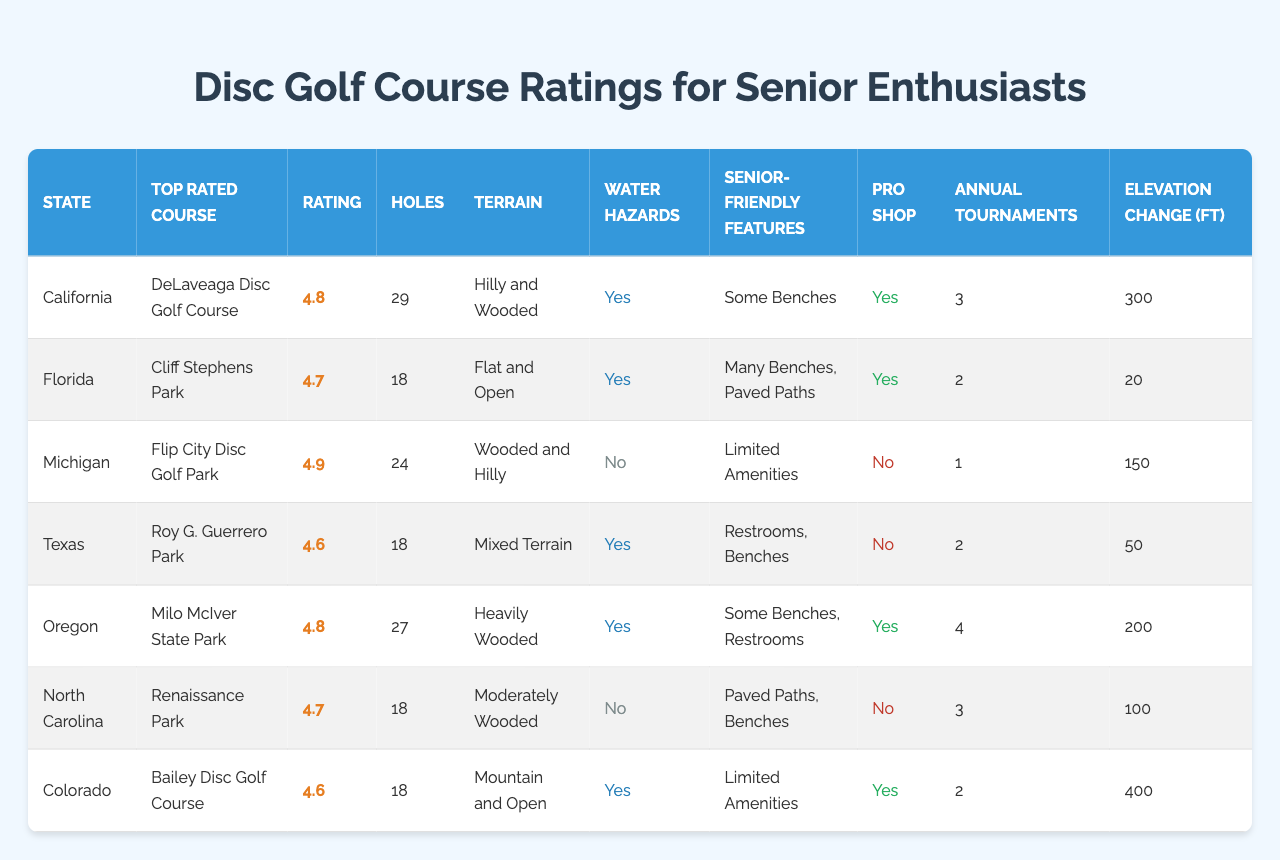What is the top-rated disc golf course in Oregon? Looking at the "Top Rated Course" column for Oregon, the entry shows "Milo McIver State Park" as the top-rated course.
Answer: Milo McIver State Park Which state has the highest course rating? The highest course rating can be found by scanning the "Course Rating" column, where Flip City Disc Golf Park in Michigan has a rating of 4.9, the highest among all states.
Answer: Michigan How many holes does the top-rated course in California have? Referring to California's entry in the "Number of Holes" column, DeLaveaga Disc Golf Course has 29 holes.
Answer: 29 Is there a pro shop on-site at the top-rated course in Florida? Checking Florida's entry under "Pro Shop on Site," it states "Yes," indicating that there is a pro shop at Cliff Stephens Park.
Answer: Yes What is the average course rating of all the courses listed? To find the average, first, sum the ratings: (4.8 + 4.7 + 4.9 + 4.6 + 4.8 + 4.7 + 4.6) = 33.1. There are 7 courses, so the average is 33.1 / 7 = 4.73.
Answer: 4.73 Which states have water hazards, and how many of them are listed? Looking at the "Water Hazards" column, the states with "Yes" entries are California, Florida, Texas, Oregon, and Colorado. That's a total of 5 states with water hazards.
Answer: 5 What is the state with the least number of annual tournaments held? By examining the "Tournaments Held Annually" column, the values for Michigan, Colorado, and Florida show the least numbers: 1 and 2. Michigan has the least with 1 tournament.
Answer: Michigan Which disc golf course has the most senior-friendly features? Analyzing the "Senior-Friendly Features" column, we see that Cliff Stephens Park in Florida offers "Many Benches, Paved Paths," which can be considered the most accommodating for seniors.
Answer: Cliff Stephens Park What is the elevation change difference between the highest and lowest listed courses? The highest elevation change is 400 feet for Bailey Disc Golf Course, and the lowest is 20 feet for Cliff Stephens Park. The difference is 400 - 20 = 380 feet.
Answer: 380 feet Are any courses listed as having limited amenities for seniors? Checking the "Senior-Friendly Features," both Flip City Disc Golf Park and Bailey Disc Golf Course have "Limited Amenities" listed, so yes, two courses are noted as such.
Answer: Yes 